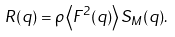Convert formula to latex. <formula><loc_0><loc_0><loc_500><loc_500>R ( q ) = \rho \left \langle F ^ { 2 } ( q ) \right \rangle S _ { M } ( q ) .</formula> 